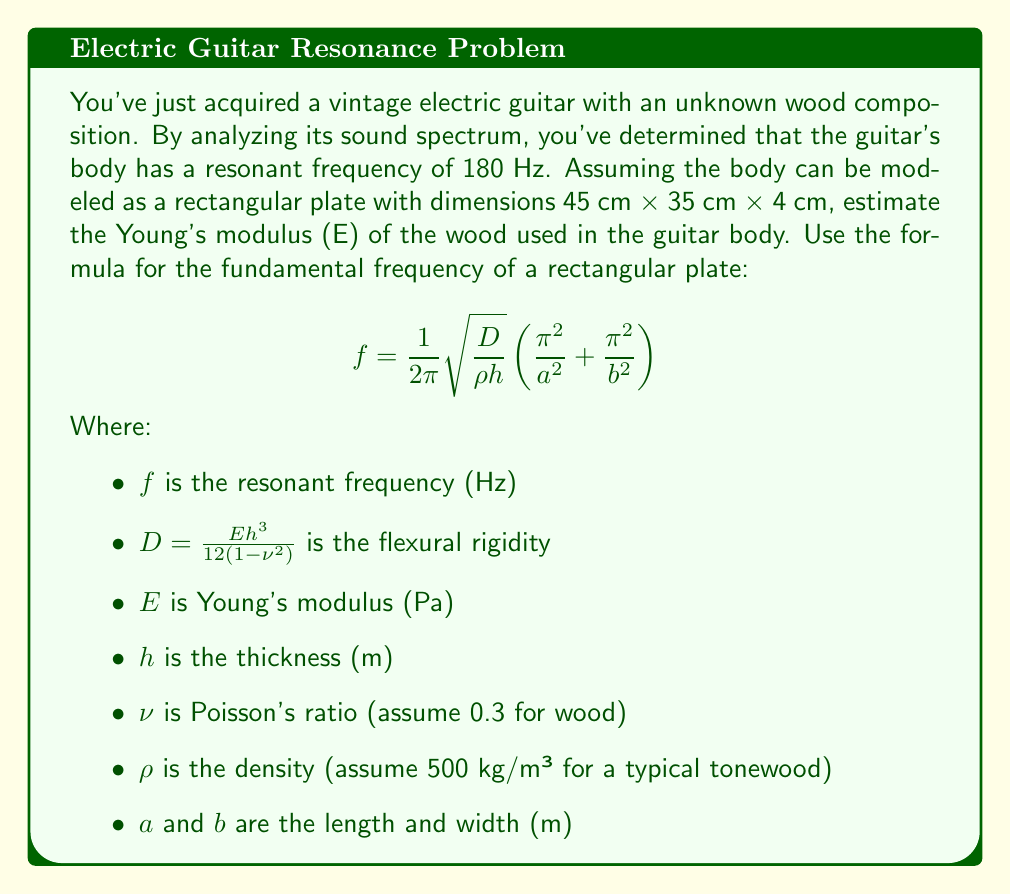Can you answer this question? Let's approach this step-by-step:

1) First, let's identify the known variables:
   $f = 180$ Hz
   $h = 0.04$ m
   $a = 0.45$ m
   $b = 0.35$ m
   $\rho = 500$ kg/m³
   $\nu = 0.3$

2) We need to solve for $E$ in the given equation. Let's start by rearranging the equation:

   $$ D = \frac{(2\pi f)^2 \rho h}{\left(\frac{\pi^2}{a^2} + \frac{\pi^2}{b^2}\right)^2} $$

3) Now, let's substitute the known values:

   $$ D = \frac{(2\pi \cdot 180)^2 \cdot 500 \cdot 0.04}{\left(\frac{\pi^2}{0.45^2} + \frac{\pi^2}{0.35^2}\right)^2} $$

4) Calculating this:

   $$ D \approx 1021.54 \text{ N·m} $$

5) Now, we can use the relationship between $D$ and $E$:

   $$ D = \frac{Eh^3}{12(1-\nu^2)} $$

6) Rearranging to solve for $E$:

   $$ E = \frac{12D(1-\nu^2)}{h^3} $$

7) Substituting the values:

   $$ E = \frac{12 \cdot 1021.54 \cdot (1-0.3^2)}{0.04^3} $$

8) Calculating this:

   $$ E \approx 10.23 \text{ GPa} $$
Answer: $10.23 \text{ GPa}$ 